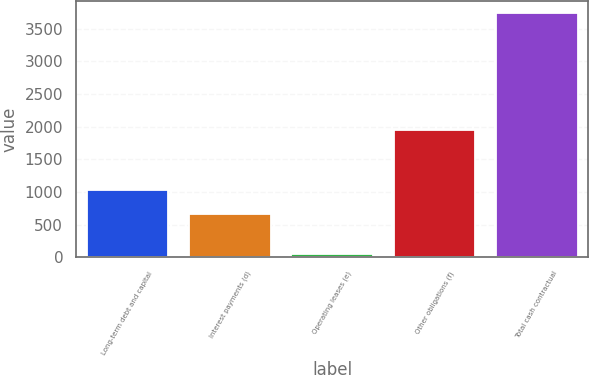<chart> <loc_0><loc_0><loc_500><loc_500><bar_chart><fcel>Long-term debt and capital<fcel>Interest payments (d)<fcel>Operating leases (e)<fcel>Other obligations (f)<fcel>Total cash contractual<nl><fcel>1032.8<fcel>664<fcel>51<fcel>1948<fcel>3739<nl></chart> 